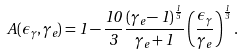<formula> <loc_0><loc_0><loc_500><loc_500>A ( \epsilon _ { \gamma } , \gamma _ { e } ) = 1 - \frac { 1 0 } { 3 } \frac { ( \gamma _ { e } - 1 ) ^ { \frac { 1 } { 5 } } } { \gamma _ { e } + 1 } \left ( \frac { \epsilon _ { \gamma } } { \gamma _ { e } } \right ) ^ { \frac { 1 } { 3 } } .</formula> 